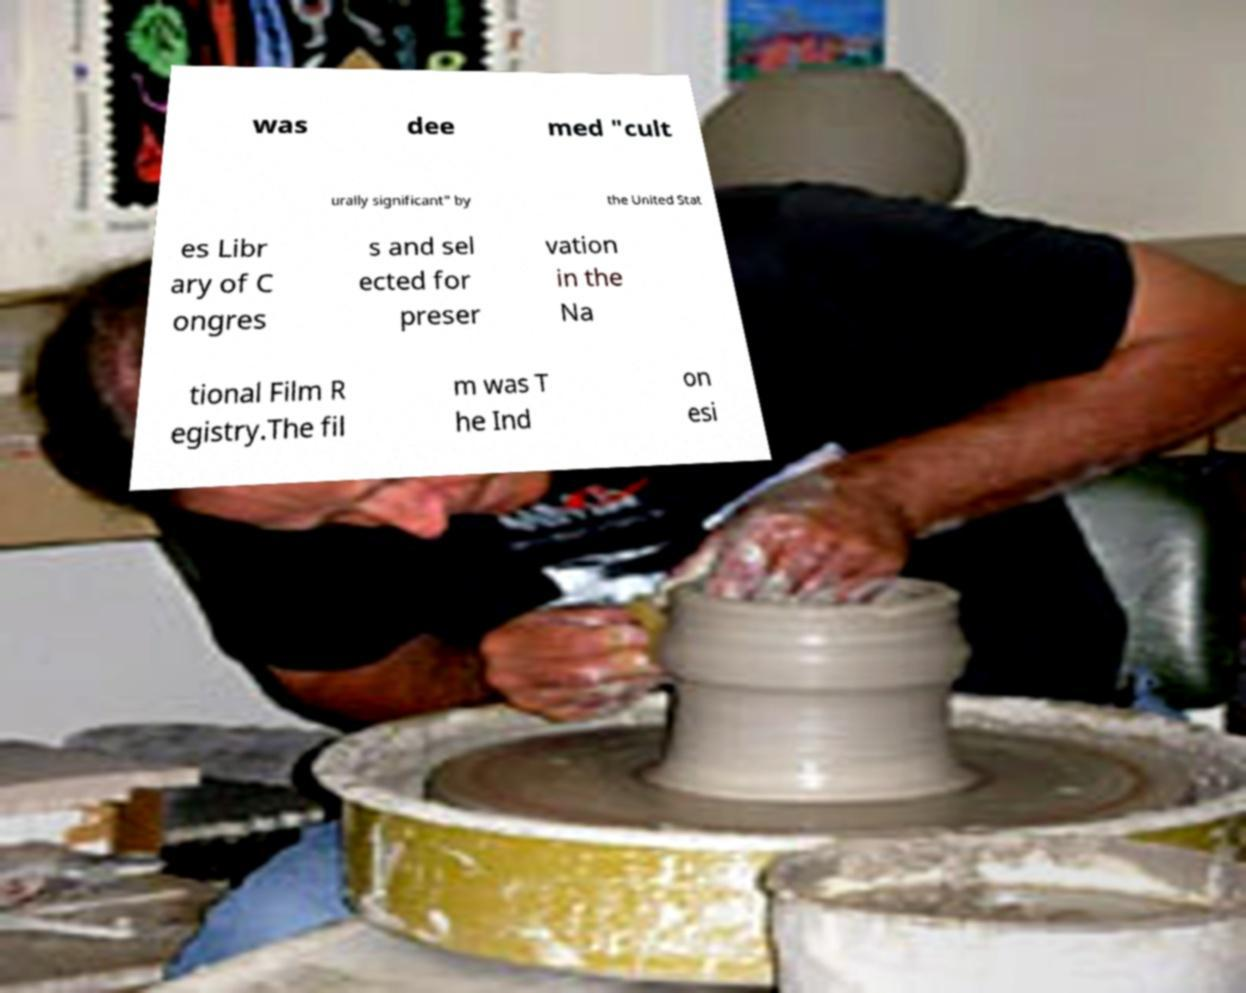Could you assist in decoding the text presented in this image and type it out clearly? was dee med "cult urally significant" by the United Stat es Libr ary of C ongres s and sel ected for preser vation in the Na tional Film R egistry.The fil m was T he Ind on esi 